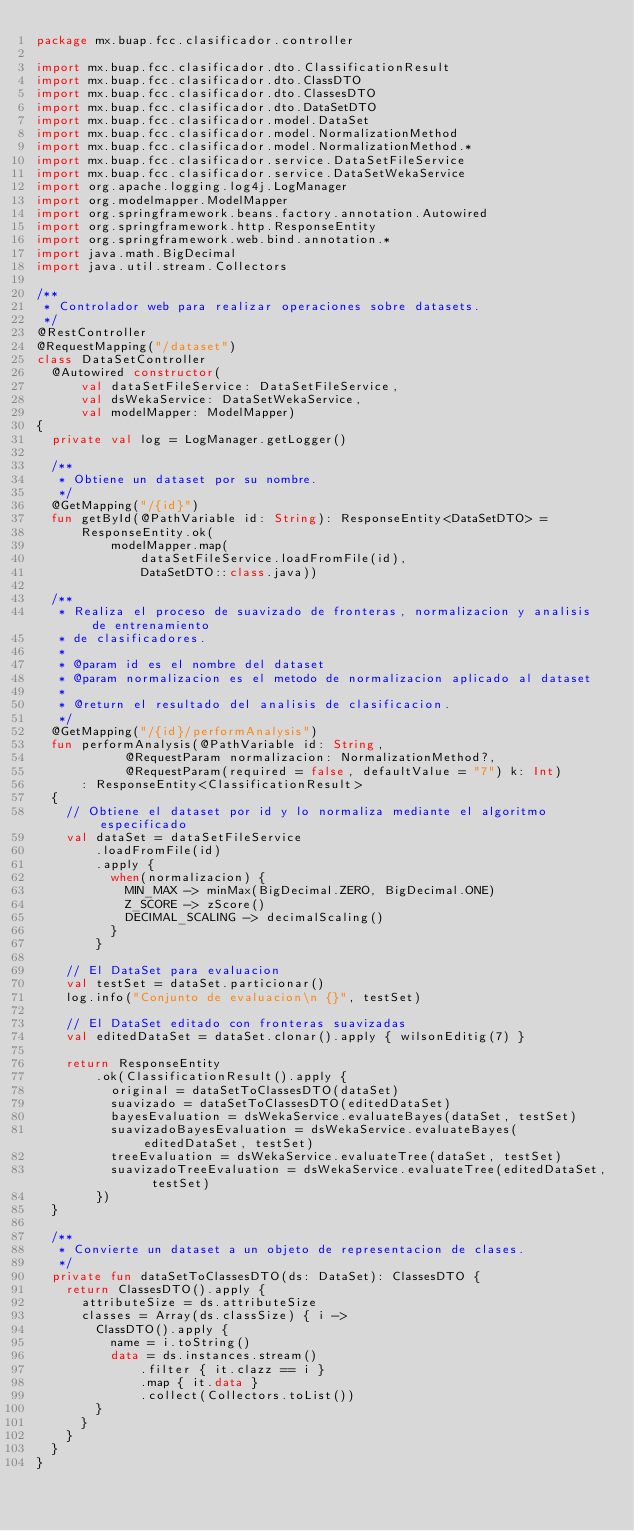Convert code to text. <code><loc_0><loc_0><loc_500><loc_500><_Kotlin_>package mx.buap.fcc.clasificador.controller

import mx.buap.fcc.clasificador.dto.ClassificationResult
import mx.buap.fcc.clasificador.dto.ClassDTO
import mx.buap.fcc.clasificador.dto.ClassesDTO
import mx.buap.fcc.clasificador.dto.DataSetDTO
import mx.buap.fcc.clasificador.model.DataSet
import mx.buap.fcc.clasificador.model.NormalizationMethod
import mx.buap.fcc.clasificador.model.NormalizationMethod.*
import mx.buap.fcc.clasificador.service.DataSetFileService
import mx.buap.fcc.clasificador.service.DataSetWekaService
import org.apache.logging.log4j.LogManager
import org.modelmapper.ModelMapper
import org.springframework.beans.factory.annotation.Autowired
import org.springframework.http.ResponseEntity
import org.springframework.web.bind.annotation.*
import java.math.BigDecimal
import java.util.stream.Collectors

/**
 * Controlador web para realizar operaciones sobre datasets.
 */
@RestController
@RequestMapping("/dataset")
class DataSetController
	@Autowired constructor(
			val dataSetFileService: DataSetFileService,
			val dsWekaService: DataSetWekaService,
			val modelMapper: ModelMapper)
{
	private val log = LogManager.getLogger()

	/**
	 * Obtiene un dataset por su nombre.
	 */
	@GetMapping("/{id}")
	fun getById(@PathVariable id: String): ResponseEntity<DataSetDTO> =
			ResponseEntity.ok(
					modelMapper.map(
							dataSetFileService.loadFromFile(id),
							DataSetDTO::class.java))

	/**
	 * Realiza el proceso de suavizado de fronteras, normalizacion y analisis de entrenamiento
	 * de clasificadores.
	 *
	 * @param id es el nombre del dataset
	 * @param normalizacion es el metodo de normalizacion aplicado al dataset
	 *
	 * @return el resultado del analisis de clasificacion.
	 */
	@GetMapping("/{id}/performAnalysis")
	fun performAnalysis(@PathVariable id: String,
						@RequestParam normalizacion: NormalizationMethod?,
						@RequestParam(required = false, defaultValue = "7") k: Int)
			: ResponseEntity<ClassificationResult>
	{
		// Obtiene el dataset por id y lo normaliza mediante el algoritmo especificado
		val dataSet = dataSetFileService
				.loadFromFile(id)
				.apply {
					when(normalizacion) {
						MIN_MAX -> minMax(BigDecimal.ZERO, BigDecimal.ONE)
						Z_SCORE -> zScore()
						DECIMAL_SCALING -> decimalScaling()
					}
				}

		// El DataSet para evaluacion
		val testSet = dataSet.particionar()
		log.info("Conjunto de evaluacion\n {}", testSet)

		// El DataSet editado con fronteras suavizadas
		val editedDataSet = dataSet.clonar().apply { wilsonEditig(7) }

		return ResponseEntity
				.ok(ClassificationResult().apply {
					original = dataSetToClassesDTO(dataSet)
					suavizado = dataSetToClassesDTO(editedDataSet)
					bayesEvaluation = dsWekaService.evaluateBayes(dataSet, testSet)
					suavizadoBayesEvaluation = dsWekaService.evaluateBayes(editedDataSet, testSet)
					treeEvaluation = dsWekaService.evaluateTree(dataSet, testSet)
					suavizadoTreeEvaluation = dsWekaService.evaluateTree(editedDataSet, testSet)
				})
	}

	/**
	 * Convierte un dataset a un objeto de representacion de clases.
	 */
	private fun dataSetToClassesDTO(ds: DataSet): ClassesDTO {
		return ClassesDTO().apply {
			attributeSize = ds.attributeSize
			classes = Array(ds.classSize) { i ->
				ClassDTO().apply {
					name = i.toString()
					data = ds.instances.stream()
							.filter { it.clazz == i }
							.map { it.data }
							.collect(Collectors.toList())
				}
			}
		}
	}
}
</code> 